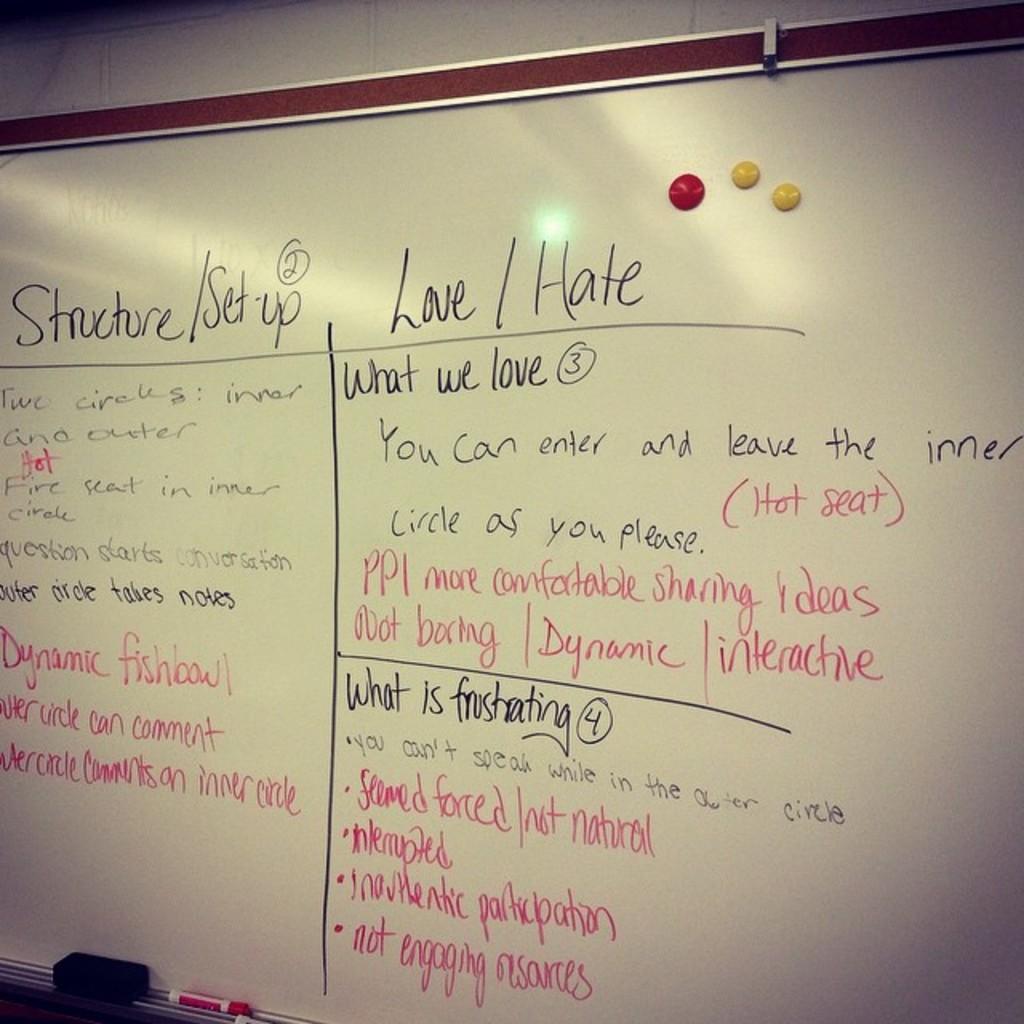What do they love in chart?
Make the answer very short. Unanswerable. What is the first word written in red?
Your answer should be compact. Hot. 